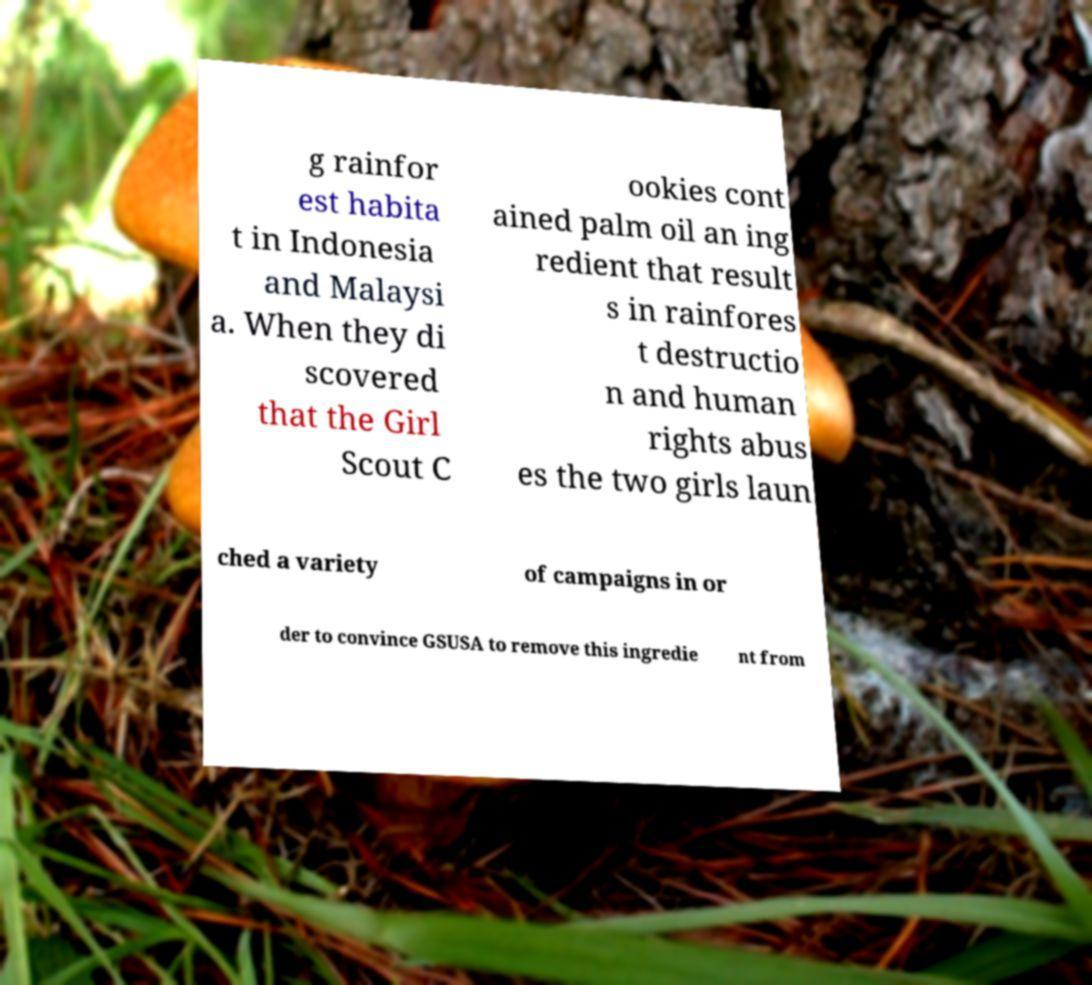Could you extract and type out the text from this image? g rainfor est habita t in Indonesia and Malaysi a. When they di scovered that the Girl Scout C ookies cont ained palm oil an ing redient that result s in rainfores t destructio n and human rights abus es the two girls laun ched a variety of campaigns in or der to convince GSUSA to remove this ingredie nt from 